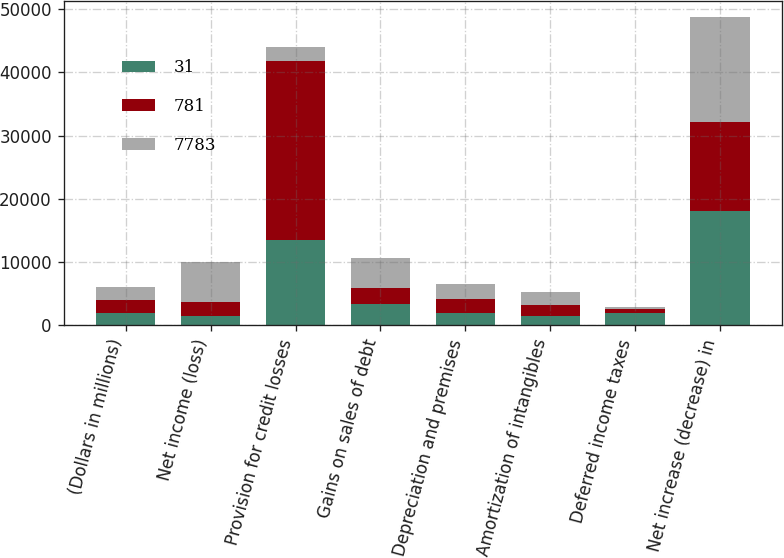Convert chart to OTSL. <chart><loc_0><loc_0><loc_500><loc_500><stacked_bar_chart><ecel><fcel>(Dollars in millions)<fcel>Net income (loss)<fcel>Provision for credit losses<fcel>Gains on sales of debt<fcel>Depreciation and premises<fcel>Amortization of intangibles<fcel>Deferred income taxes<fcel>Net increase (decrease) in<nl><fcel>31<fcel>2011<fcel>1446<fcel>13410<fcel>3374<fcel>1976<fcel>1509<fcel>1949<fcel>18124<nl><fcel>781<fcel>2010<fcel>2238<fcel>28435<fcel>2526<fcel>2181<fcel>1731<fcel>608<fcel>14069<nl><fcel>7783<fcel>2009<fcel>6276<fcel>2181<fcel>4723<fcel>2336<fcel>1978<fcel>370<fcel>16601<nl></chart> 